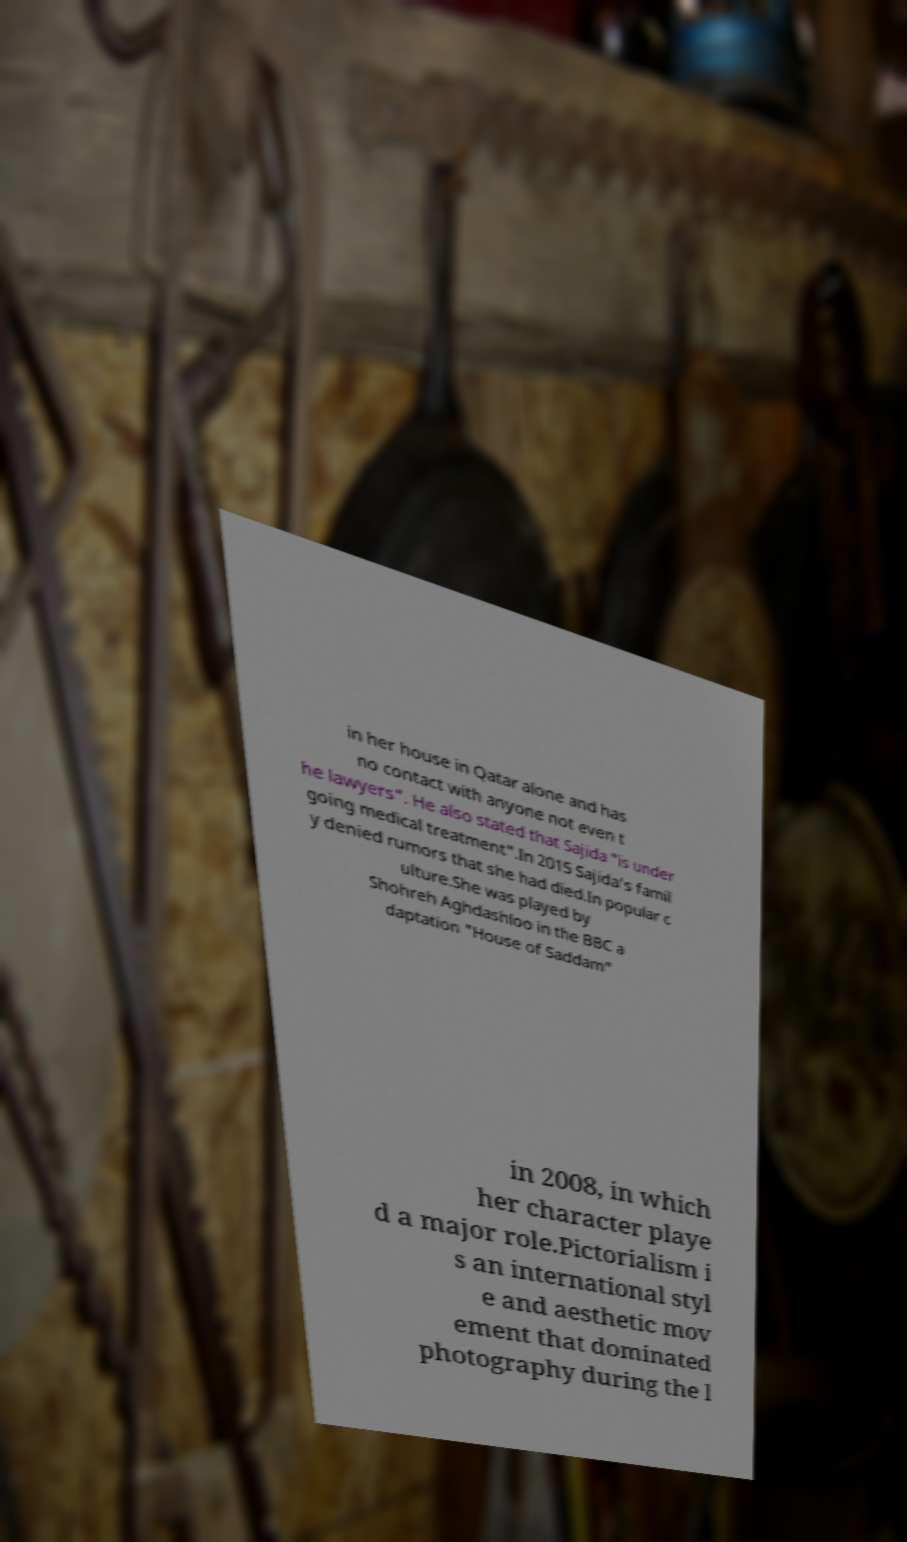There's text embedded in this image that I need extracted. Can you transcribe it verbatim? in her house in Qatar alone and has no contact with anyone not even t he lawyers". He also stated that Sajida "is under going medical treatment".In 2015 Sajida's famil y denied rumors that she had died.In popular c ulture.She was played by Shohreh Aghdashloo in the BBC a daptation "House of Saddam" in 2008, in which her character playe d a major role.Pictorialism i s an international styl e and aesthetic mov ement that dominated photography during the l 